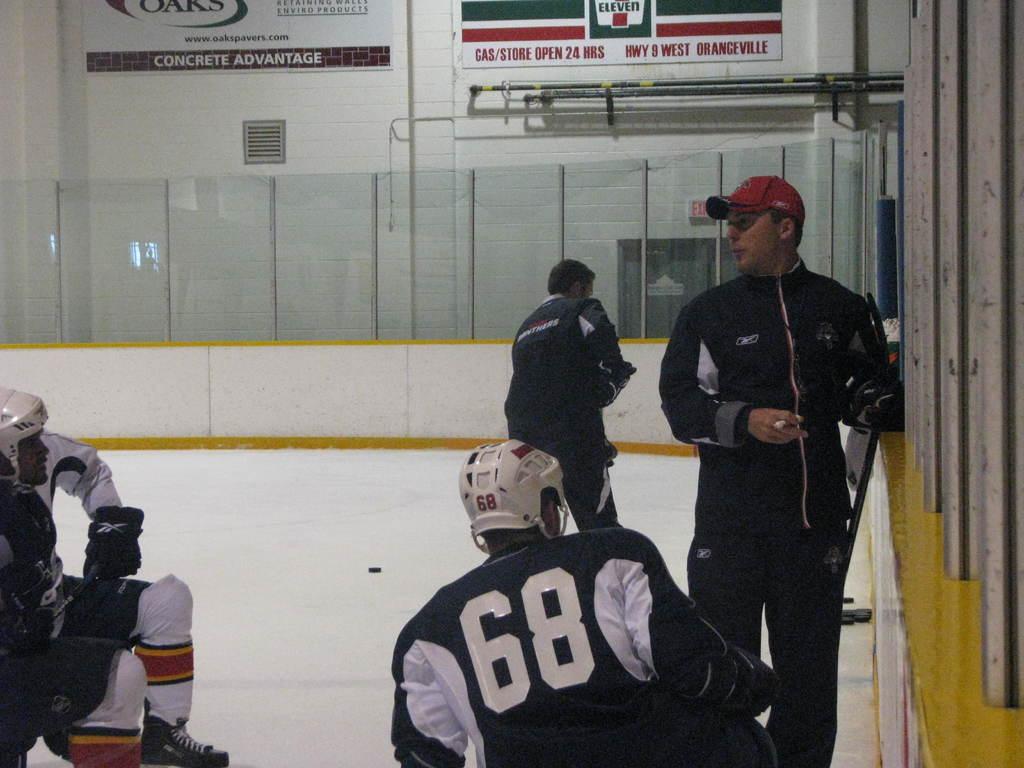What number is the player?
Your answer should be very brief. 68. 